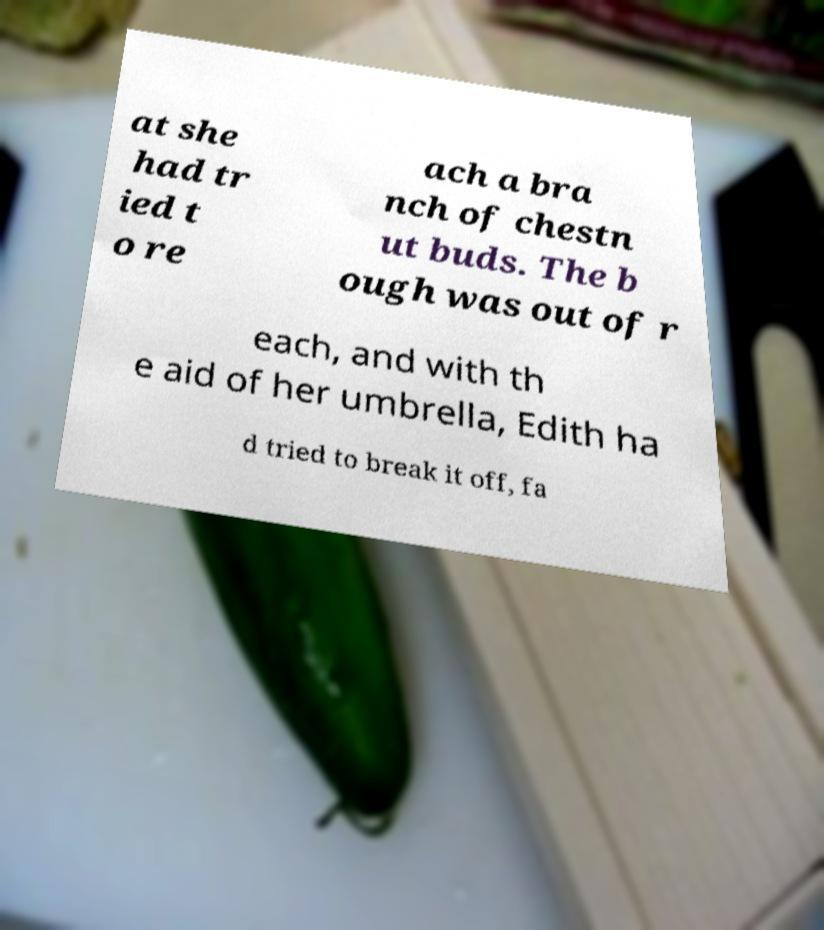Could you assist in decoding the text presented in this image and type it out clearly? at she had tr ied t o re ach a bra nch of chestn ut buds. The b ough was out of r each, and with th e aid of her umbrella, Edith ha d tried to break it off, fa 